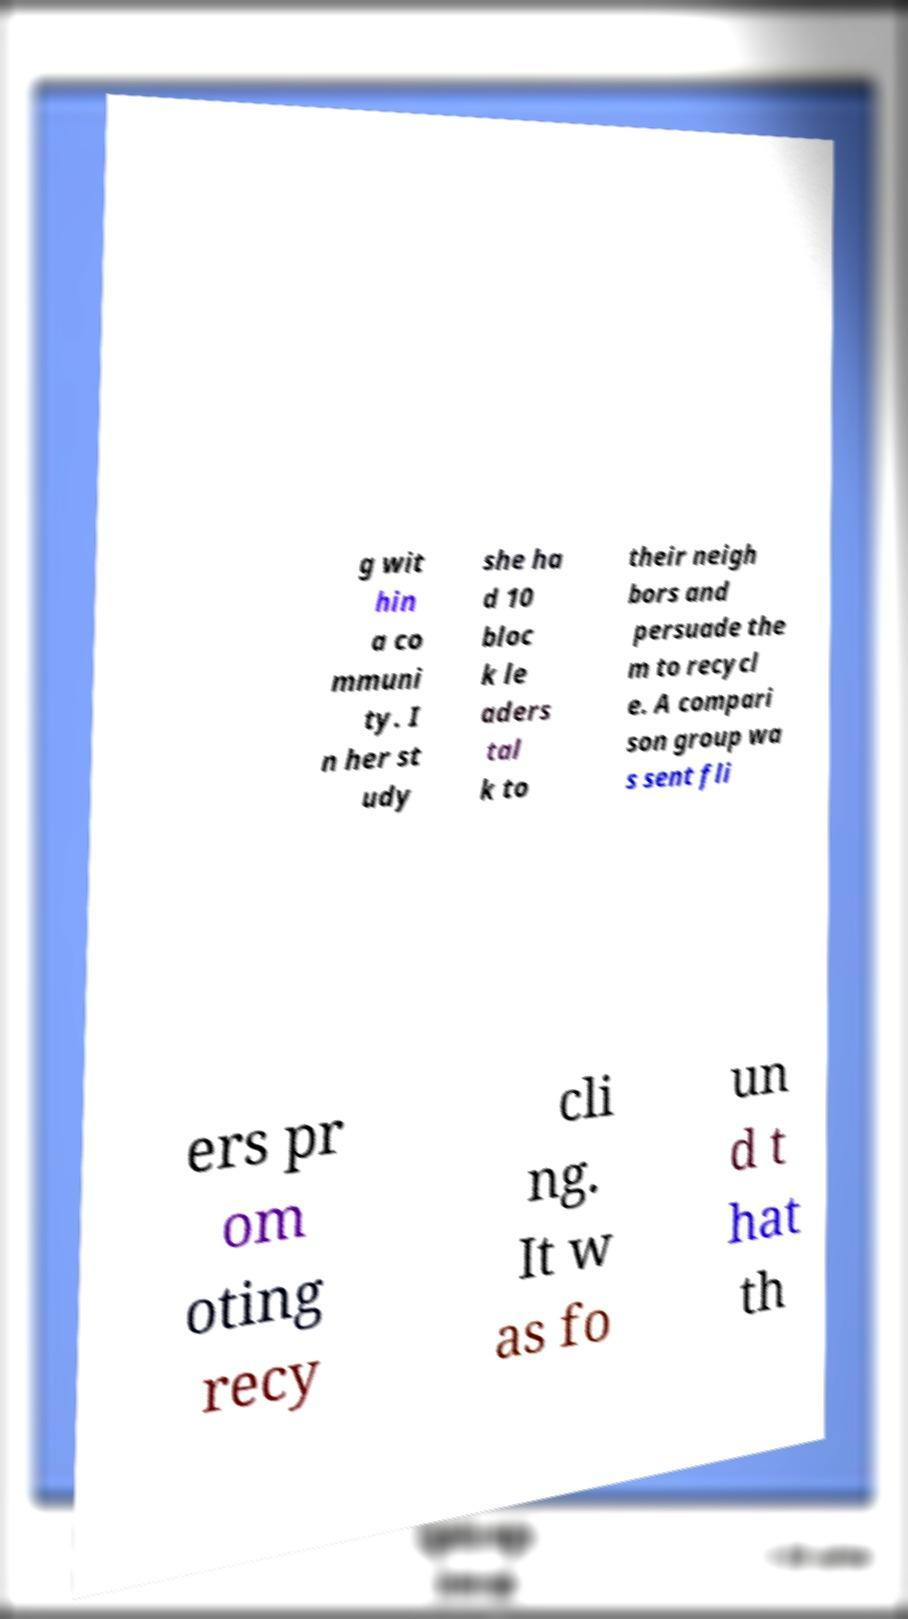Could you extract and type out the text from this image? g wit hin a co mmuni ty. I n her st udy she ha d 10 bloc k le aders tal k to their neigh bors and persuade the m to recycl e. A compari son group wa s sent fli ers pr om oting recy cli ng. It w as fo un d t hat th 